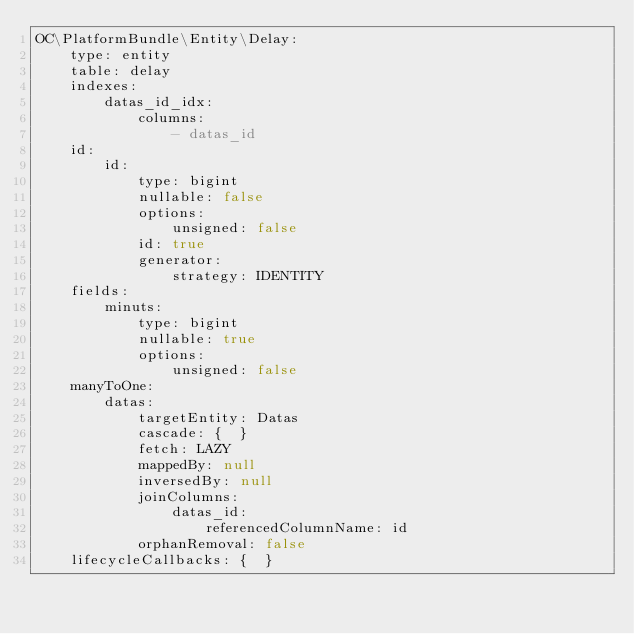Convert code to text. <code><loc_0><loc_0><loc_500><loc_500><_YAML_>OC\PlatformBundle\Entity\Delay:
    type: entity
    table: delay
    indexes:
        datas_id_idx:
            columns:
                - datas_id
    id:
        id:
            type: bigint
            nullable: false
            options:
                unsigned: false
            id: true
            generator:
                strategy: IDENTITY
    fields:
        minuts:
            type: bigint
            nullable: true
            options:
                unsigned: false
    manyToOne:
        datas:
            targetEntity: Datas
            cascade: {  }
            fetch: LAZY
            mappedBy: null
            inversedBy: null
            joinColumns:
                datas_id:
                    referencedColumnName: id
            orphanRemoval: false
    lifecycleCallbacks: {  }
</code> 